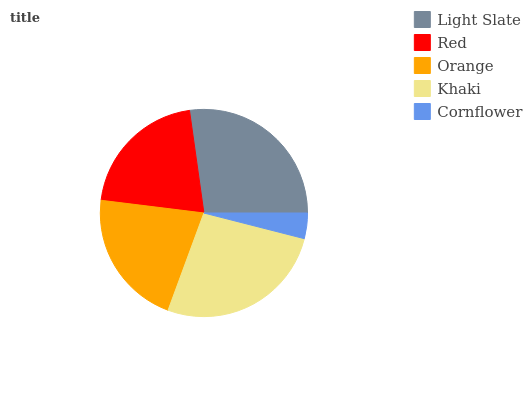Is Cornflower the minimum?
Answer yes or no. Yes. Is Light Slate the maximum?
Answer yes or no. Yes. Is Red the minimum?
Answer yes or no. No. Is Red the maximum?
Answer yes or no. No. Is Light Slate greater than Red?
Answer yes or no. Yes. Is Red less than Light Slate?
Answer yes or no. Yes. Is Red greater than Light Slate?
Answer yes or no. No. Is Light Slate less than Red?
Answer yes or no. No. Is Orange the high median?
Answer yes or no. Yes. Is Orange the low median?
Answer yes or no. Yes. Is Light Slate the high median?
Answer yes or no. No. Is Red the low median?
Answer yes or no. No. 